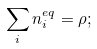<formula> <loc_0><loc_0><loc_500><loc_500>\sum _ { i } n _ { i } ^ { e q } = \rho ;</formula> 